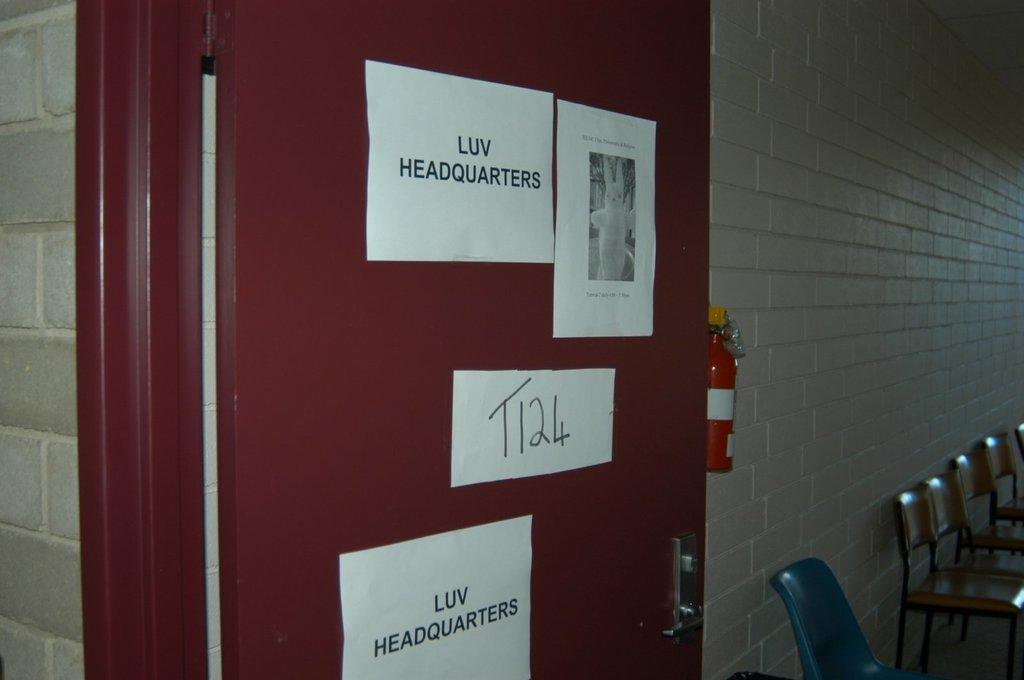What color is the door in the image? The door in the image is maroon colored. What is placed on the door? There are white color papers on the door. What type of furniture can be seen in the image? Chairs are present in the image. What safety equipment is visible in the image? There is an emergency gas cylinder in the image. What color is the wall in the image? The wall in the image is grey colored. How many rabbits can be seen playing with a marble in the image? There are no rabbits or marbles present in the image; it features a maroon door with white papers, chairs, an emergency gas cylinder, and a grey wall. 